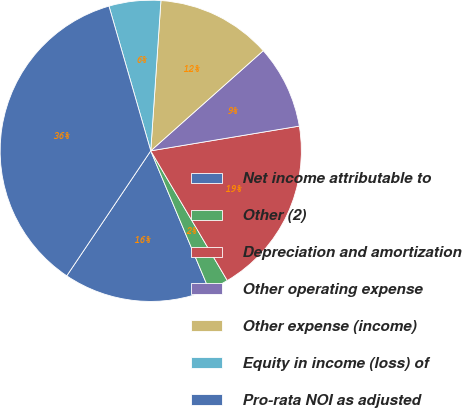<chart> <loc_0><loc_0><loc_500><loc_500><pie_chart><fcel>Net income attributable to<fcel>Other (2)<fcel>Depreciation and amortization<fcel>Other operating expense<fcel>Other expense (income)<fcel>Equity in income (loss) of<fcel>Pro-rata NOI as adjusted<nl><fcel>15.74%<fcel>2.16%<fcel>19.14%<fcel>8.95%<fcel>12.35%<fcel>5.55%<fcel>36.11%<nl></chart> 